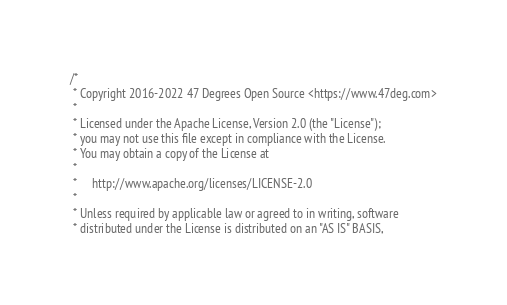<code> <loc_0><loc_0><loc_500><loc_500><_Scala_>/*
 * Copyright 2016-2022 47 Degrees Open Source <https://www.47deg.com>
 *
 * Licensed under the Apache License, Version 2.0 (the "License");
 * you may not use this file except in compliance with the License.
 * You may obtain a copy of the License at
 *
 *     http://www.apache.org/licenses/LICENSE-2.0
 *
 * Unless required by applicable law or agreed to in writing, software
 * distributed under the License is distributed on an "AS IS" BASIS,</code> 